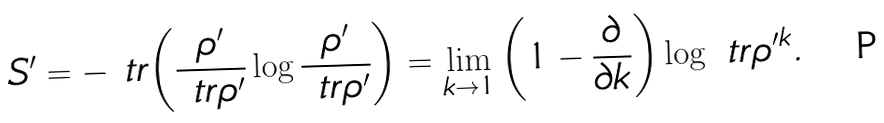<formula> <loc_0><loc_0><loc_500><loc_500>S ^ { \prime } = - \ t r { \left ( \frac { \rho ^ { \prime } } { \ t r { \rho ^ { \prime } } } \log { \frac { \rho ^ { \prime } } { \ t r { \rho ^ { \prime } } } } \right ) } = \lim _ { k \to 1 } \left ( 1 - \frac { \partial } { \partial k } \right ) \log { \ t r { \rho ^ { \prime k } } } .</formula> 